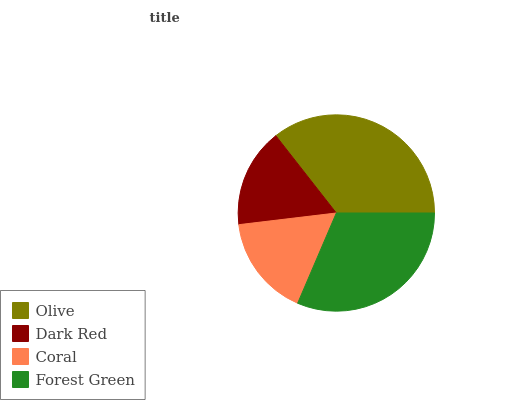Is Dark Red the minimum?
Answer yes or no. Yes. Is Olive the maximum?
Answer yes or no. Yes. Is Coral the minimum?
Answer yes or no. No. Is Coral the maximum?
Answer yes or no. No. Is Coral greater than Dark Red?
Answer yes or no. Yes. Is Dark Red less than Coral?
Answer yes or no. Yes. Is Dark Red greater than Coral?
Answer yes or no. No. Is Coral less than Dark Red?
Answer yes or no. No. Is Forest Green the high median?
Answer yes or no. Yes. Is Coral the low median?
Answer yes or no. Yes. Is Dark Red the high median?
Answer yes or no. No. Is Olive the low median?
Answer yes or no. No. 